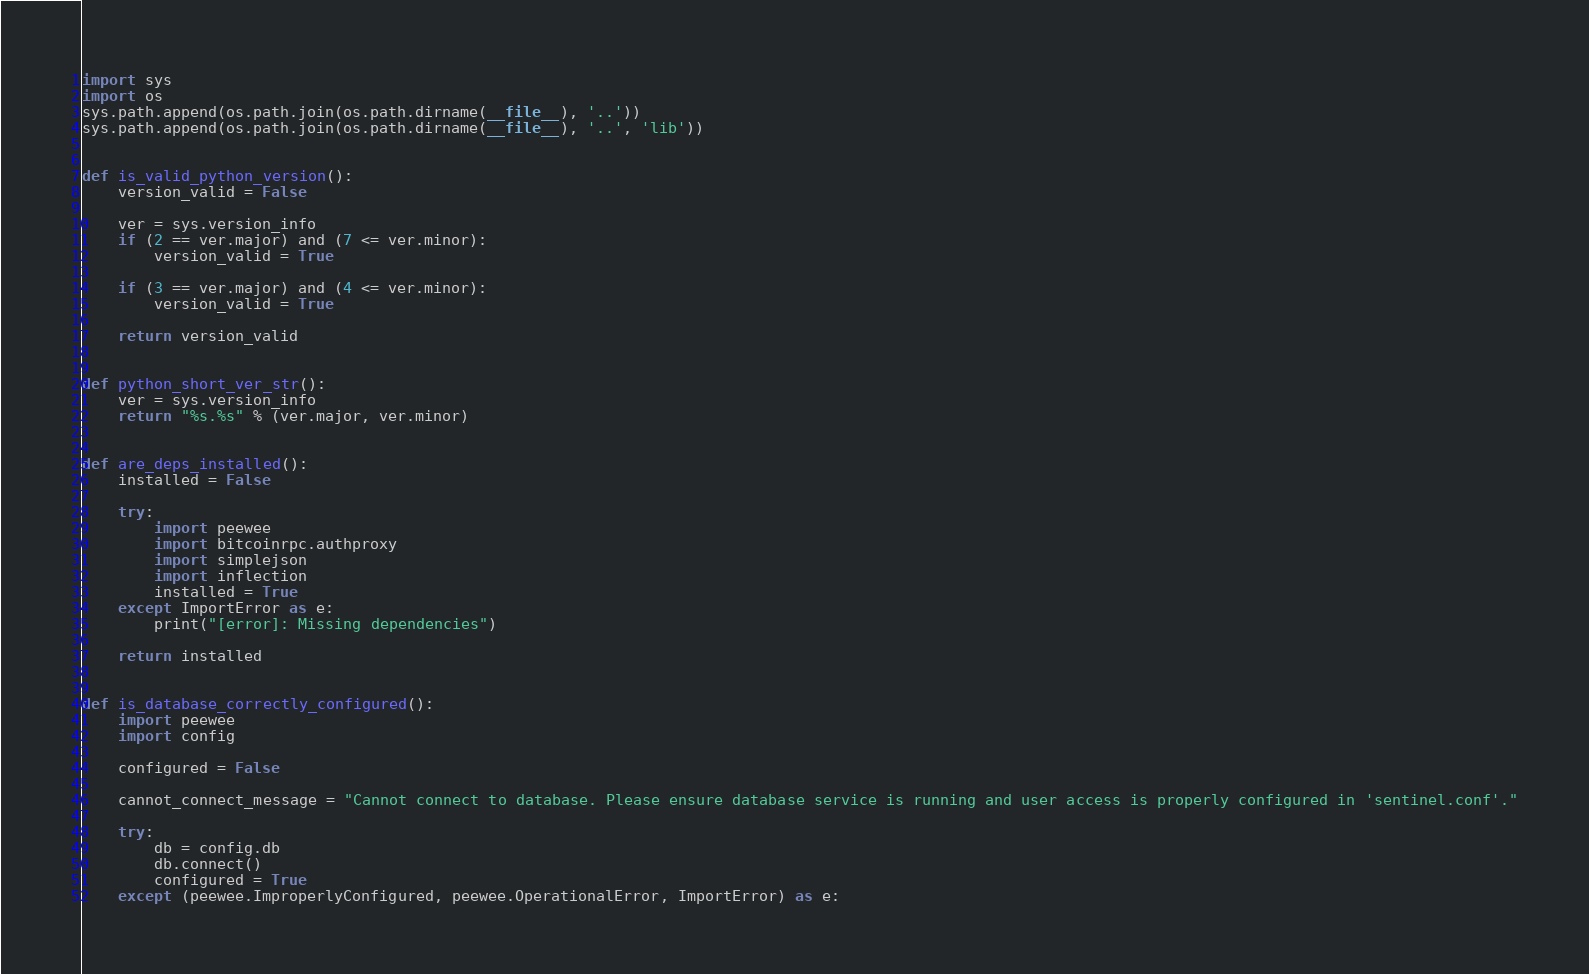<code> <loc_0><loc_0><loc_500><loc_500><_Python_>import sys
import os
sys.path.append(os.path.join(os.path.dirname(__file__), '..'))
sys.path.append(os.path.join(os.path.dirname(__file__), '..', 'lib'))


def is_valid_python_version():
    version_valid = False

    ver = sys.version_info
    if (2 == ver.major) and (7 <= ver.minor):
        version_valid = True

    if (3 == ver.major) and (4 <= ver.minor):
        version_valid = True

    return version_valid


def python_short_ver_str():
    ver = sys.version_info
    return "%s.%s" % (ver.major, ver.minor)


def are_deps_installed():
    installed = False

    try:
        import peewee
        import bitcoinrpc.authproxy
        import simplejson
        import inflection
        installed = True
    except ImportError as e:
        print("[error]: Missing dependencies")

    return installed


def is_database_correctly_configured():
    import peewee
    import config

    configured = False

    cannot_connect_message = "Cannot connect to database. Please ensure database service is running and user access is properly configured in 'sentinel.conf'."

    try:
        db = config.db
        db.connect()
        configured = True
    except (peewee.ImproperlyConfigured, peewee.OperationalError, ImportError) as e:</code> 